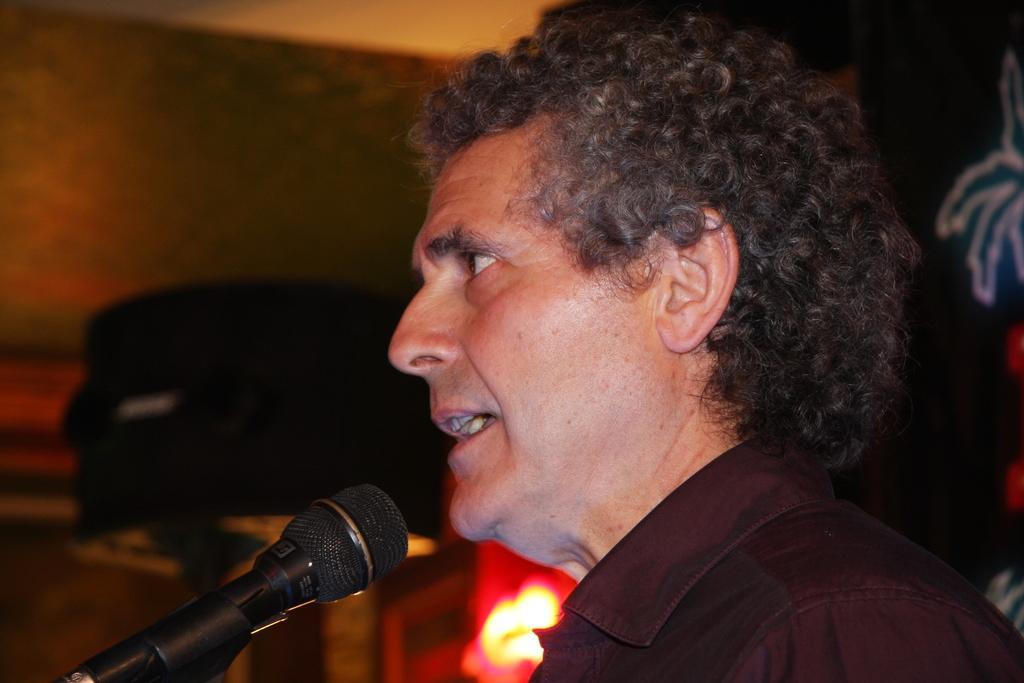Please provide a concise description of this image. In the image there is a man it looks like he is talking something, there is a mic in front of him and the background of the man is blur. 